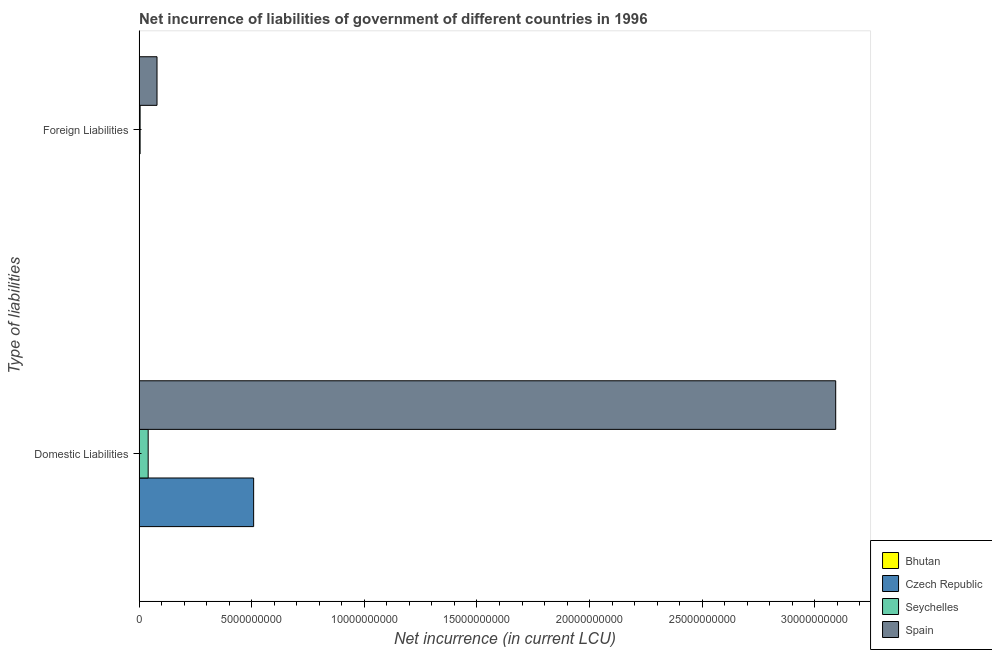How many different coloured bars are there?
Your answer should be compact. 3. How many groups of bars are there?
Offer a very short reply. 2. Are the number of bars per tick equal to the number of legend labels?
Ensure brevity in your answer.  No. What is the label of the 1st group of bars from the top?
Offer a very short reply. Foreign Liabilities. Across all countries, what is the maximum net incurrence of foreign liabilities?
Provide a succinct answer. 7.95e+08. Across all countries, what is the minimum net incurrence of domestic liabilities?
Give a very brief answer. 0. What is the total net incurrence of foreign liabilities in the graph?
Offer a terse response. 8.40e+08. What is the difference between the net incurrence of domestic liabilities in Czech Republic and that in Spain?
Keep it short and to the point. -2.58e+1. What is the difference between the net incurrence of domestic liabilities in Seychelles and the net incurrence of foreign liabilities in Czech Republic?
Give a very brief answer. 4.02e+08. What is the average net incurrence of domestic liabilities per country?
Offer a very short reply. 9.10e+09. What is the difference between the net incurrence of foreign liabilities and net incurrence of domestic liabilities in Spain?
Provide a succinct answer. -3.01e+1. What is the ratio of the net incurrence of foreign liabilities in Seychelles to that in Spain?
Offer a very short reply. 0.06. In how many countries, is the net incurrence of domestic liabilities greater than the average net incurrence of domestic liabilities taken over all countries?
Give a very brief answer. 1. How many countries are there in the graph?
Your answer should be compact. 4. What is the difference between two consecutive major ticks on the X-axis?
Provide a short and direct response. 5.00e+09. Does the graph contain any zero values?
Provide a succinct answer. Yes. Does the graph contain grids?
Keep it short and to the point. No. Where does the legend appear in the graph?
Offer a terse response. Bottom right. What is the title of the graph?
Offer a terse response. Net incurrence of liabilities of government of different countries in 1996. What is the label or title of the X-axis?
Make the answer very short. Net incurrence (in current LCU). What is the label or title of the Y-axis?
Give a very brief answer. Type of liabilities. What is the Net incurrence (in current LCU) of Bhutan in Domestic Liabilities?
Make the answer very short. 0. What is the Net incurrence (in current LCU) of Czech Republic in Domestic Liabilities?
Give a very brief answer. 5.08e+09. What is the Net incurrence (in current LCU) in Seychelles in Domestic Liabilities?
Provide a succinct answer. 4.02e+08. What is the Net incurrence (in current LCU) of Spain in Domestic Liabilities?
Offer a terse response. 3.09e+1. What is the Net incurrence (in current LCU) in Bhutan in Foreign Liabilities?
Give a very brief answer. 0. What is the Net incurrence (in current LCU) in Seychelles in Foreign Liabilities?
Offer a terse response. 4.45e+07. What is the Net incurrence (in current LCU) of Spain in Foreign Liabilities?
Your response must be concise. 7.95e+08. Across all Type of liabilities, what is the maximum Net incurrence (in current LCU) of Czech Republic?
Provide a short and direct response. 5.08e+09. Across all Type of liabilities, what is the maximum Net incurrence (in current LCU) in Seychelles?
Provide a short and direct response. 4.02e+08. Across all Type of liabilities, what is the maximum Net incurrence (in current LCU) of Spain?
Make the answer very short. 3.09e+1. Across all Type of liabilities, what is the minimum Net incurrence (in current LCU) in Seychelles?
Offer a terse response. 4.45e+07. Across all Type of liabilities, what is the minimum Net incurrence (in current LCU) in Spain?
Your answer should be very brief. 7.95e+08. What is the total Net incurrence (in current LCU) of Czech Republic in the graph?
Make the answer very short. 5.08e+09. What is the total Net incurrence (in current LCU) of Seychelles in the graph?
Make the answer very short. 4.47e+08. What is the total Net incurrence (in current LCU) in Spain in the graph?
Your response must be concise. 3.17e+1. What is the difference between the Net incurrence (in current LCU) in Seychelles in Domestic Liabilities and that in Foreign Liabilities?
Offer a very short reply. 3.58e+08. What is the difference between the Net incurrence (in current LCU) of Spain in Domestic Liabilities and that in Foreign Liabilities?
Offer a terse response. 3.01e+1. What is the difference between the Net incurrence (in current LCU) of Czech Republic in Domestic Liabilities and the Net incurrence (in current LCU) of Seychelles in Foreign Liabilities?
Ensure brevity in your answer.  5.04e+09. What is the difference between the Net incurrence (in current LCU) of Czech Republic in Domestic Liabilities and the Net incurrence (in current LCU) of Spain in Foreign Liabilities?
Your answer should be compact. 4.29e+09. What is the difference between the Net incurrence (in current LCU) in Seychelles in Domestic Liabilities and the Net incurrence (in current LCU) in Spain in Foreign Liabilities?
Ensure brevity in your answer.  -3.93e+08. What is the average Net incurrence (in current LCU) of Czech Republic per Type of liabilities?
Provide a succinct answer. 2.54e+09. What is the average Net incurrence (in current LCU) of Seychelles per Type of liabilities?
Keep it short and to the point. 2.24e+08. What is the average Net incurrence (in current LCU) of Spain per Type of liabilities?
Your answer should be compact. 1.59e+1. What is the difference between the Net incurrence (in current LCU) of Czech Republic and Net incurrence (in current LCU) of Seychelles in Domestic Liabilities?
Keep it short and to the point. 4.68e+09. What is the difference between the Net incurrence (in current LCU) in Czech Republic and Net incurrence (in current LCU) in Spain in Domestic Liabilities?
Your answer should be compact. -2.58e+1. What is the difference between the Net incurrence (in current LCU) of Seychelles and Net incurrence (in current LCU) of Spain in Domestic Liabilities?
Give a very brief answer. -3.05e+1. What is the difference between the Net incurrence (in current LCU) in Seychelles and Net incurrence (in current LCU) in Spain in Foreign Liabilities?
Keep it short and to the point. -7.51e+08. What is the ratio of the Net incurrence (in current LCU) of Seychelles in Domestic Liabilities to that in Foreign Liabilities?
Your response must be concise. 9.04. What is the ratio of the Net incurrence (in current LCU) in Spain in Domestic Liabilities to that in Foreign Liabilities?
Your answer should be compact. 38.89. What is the difference between the highest and the second highest Net incurrence (in current LCU) of Seychelles?
Provide a succinct answer. 3.58e+08. What is the difference between the highest and the second highest Net incurrence (in current LCU) of Spain?
Your response must be concise. 3.01e+1. What is the difference between the highest and the lowest Net incurrence (in current LCU) in Czech Republic?
Your answer should be very brief. 5.08e+09. What is the difference between the highest and the lowest Net incurrence (in current LCU) in Seychelles?
Provide a succinct answer. 3.58e+08. What is the difference between the highest and the lowest Net incurrence (in current LCU) in Spain?
Keep it short and to the point. 3.01e+1. 